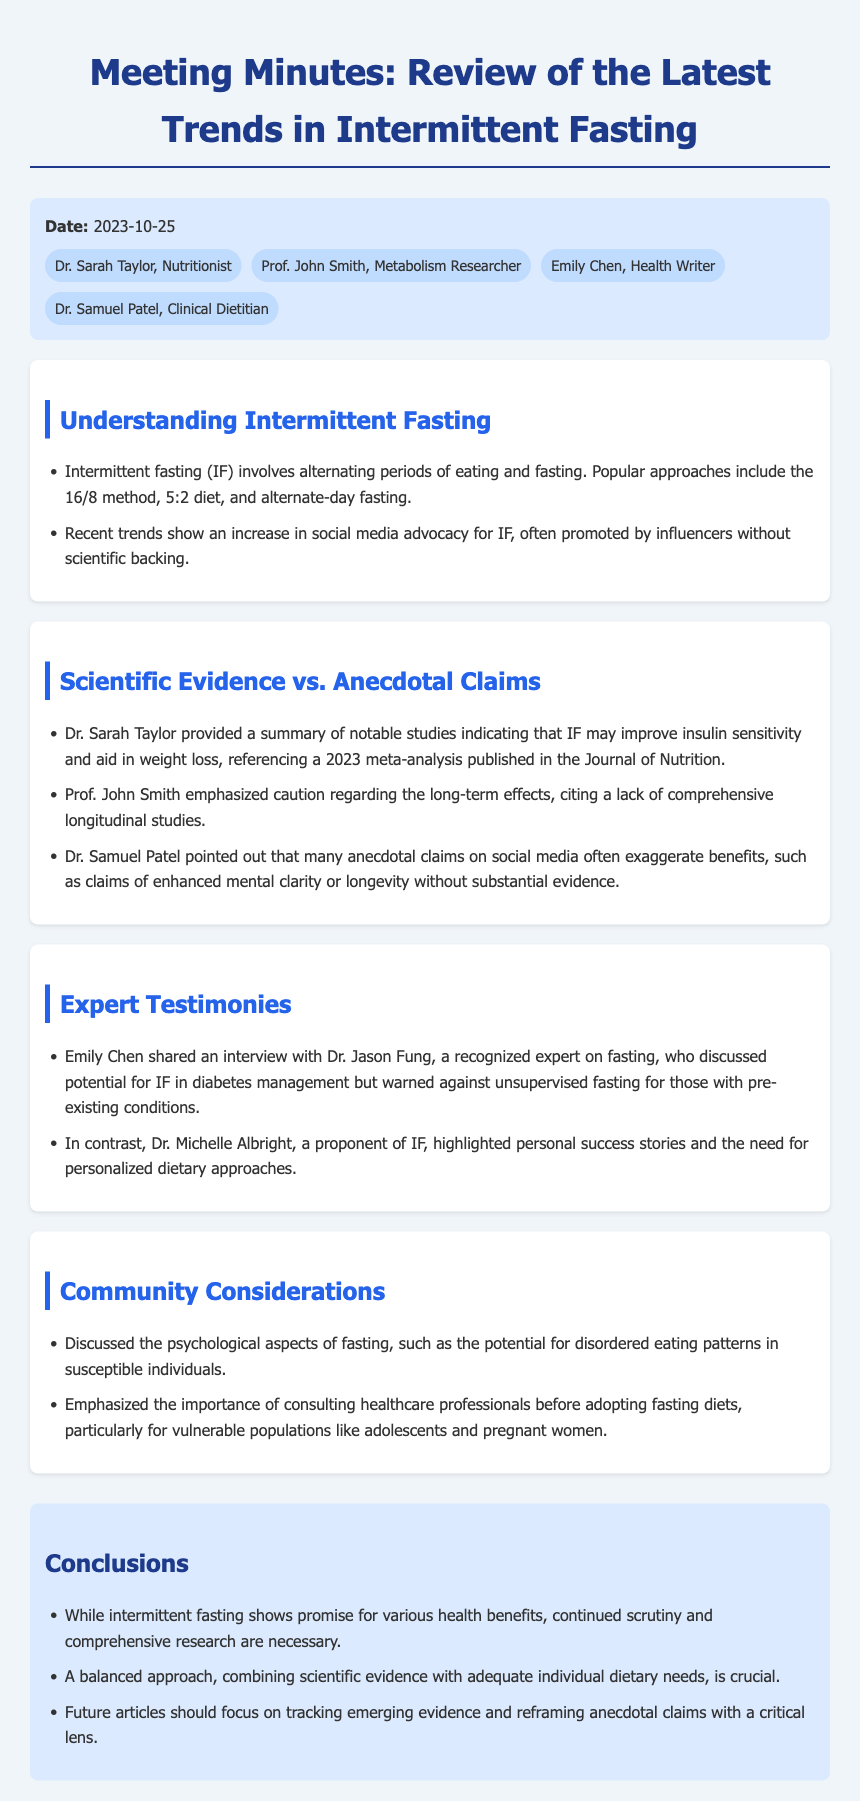What is the date of the meeting? The date is specified in the meta-info section of the document.
Answer: 2023-10-25 Who emphasized caution regarding the long-term effects of intermittent fasting? This information is found in the key discussion section featuring expert testimonies.
Answer: Prof. John Smith What are some of the popular approaches to intermittent fasting mentioned? The document lists several methods in the key discussion about understanding intermittent fasting.
Answer: 16/8 method, 5:2 diet, alternate-day fasting What did Dr. Samuel Patel point out about anecdotal claims? This is mentioned in the "Scientific Evidence vs. Anecdotal Claims" section discussing the exaggeration of benefits.
Answer: Exaggerate benefits What did the meeting conclude about intermittent fasting? The conclusions section summarizes the overall perspective on intermittent fasting as discussed in the meeting.
Answer: Continued scrutiny and comprehensive research are necessary Who shared an interview with Dr. Jason Fung? The expert testimonies section attributes this contribution to a specific attendee.
Answer: Emily Chen What psychological aspect of fasting was discussed during the meeting? It is mentioned under the community considerations in the meeting minutes.
Answer: Potential for disordered eating patterns How many attendees were listed in the document? This information can be found in the meta-info section detailing attendees.
Answer: Four attendees 